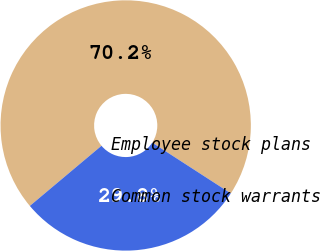<chart> <loc_0><loc_0><loc_500><loc_500><pie_chart><fcel>Employee stock plans<fcel>Common stock warrants<nl><fcel>70.25%<fcel>29.75%<nl></chart> 